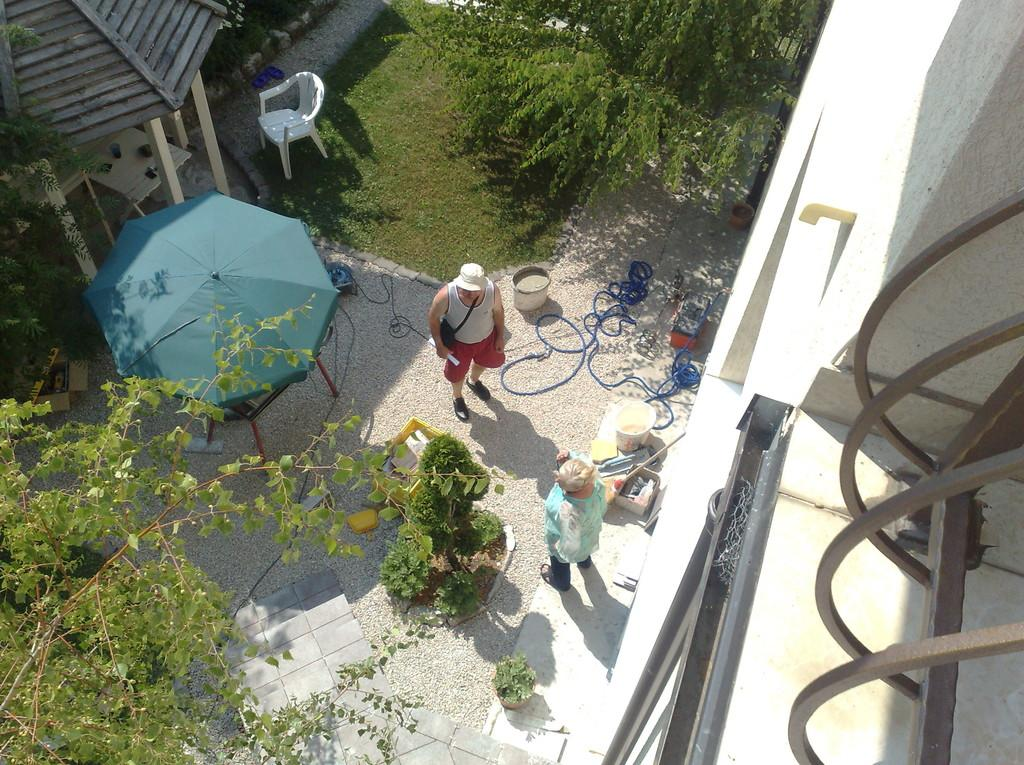What type of vegetation can be seen in the image? There are trees in the image. What type of furniture is present in the image? There is a chair in the image. What type of accessory is present in the image? There is an umbrella in the image. What type of structure is visible in the image? There is a building in the image. What type of container is present in the image? There is a bucket in the image. How many people are present in the image? There are two people standing in the image. What type of linen is being used to cover the giants at the feast in the image? There are no giants or feast present in the image, so there is no linen covering them. 